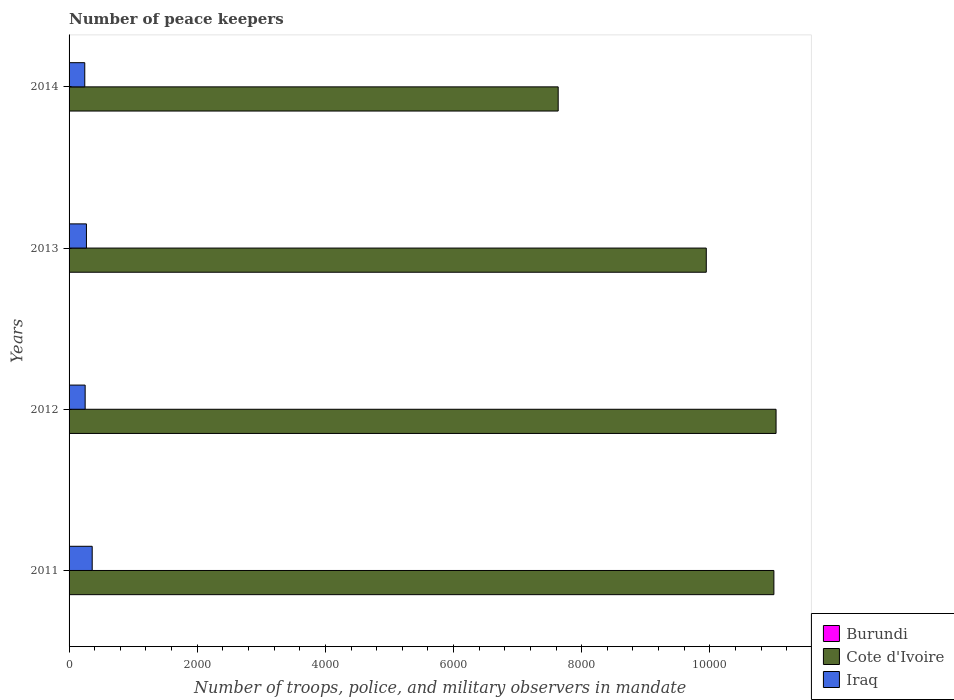How many groups of bars are there?
Ensure brevity in your answer.  4. Are the number of bars per tick equal to the number of legend labels?
Ensure brevity in your answer.  Yes. What is the label of the 3rd group of bars from the top?
Offer a terse response. 2012. What is the number of peace keepers in in Cote d'Ivoire in 2013?
Provide a succinct answer. 9944. Across all years, what is the maximum number of peace keepers in in Cote d'Ivoire?
Provide a succinct answer. 1.10e+04. Across all years, what is the minimum number of peace keepers in in Cote d'Ivoire?
Provide a succinct answer. 7633. In which year was the number of peace keepers in in Cote d'Ivoire maximum?
Provide a succinct answer. 2012. What is the total number of peace keepers in in Iraq in the graph?
Provide a succinct answer. 1128. What is the difference between the number of peace keepers in in Burundi in 2012 and that in 2014?
Provide a short and direct response. 0. What is the difference between the number of peace keepers in in Cote d'Ivoire in 2014 and the number of peace keepers in in Burundi in 2012?
Your answer should be compact. 7631. What is the average number of peace keepers in in Cote d'Ivoire per year?
Offer a terse response. 9902.25. In the year 2013, what is the difference between the number of peace keepers in in Burundi and number of peace keepers in in Cote d'Ivoire?
Make the answer very short. -9942. What is the ratio of the number of peace keepers in in Cote d'Ivoire in 2011 to that in 2012?
Provide a succinct answer. 1. Is the number of peace keepers in in Burundi in 2013 less than that in 2014?
Provide a short and direct response. No. What is the difference between the highest and the second highest number of peace keepers in in Cote d'Ivoire?
Offer a terse response. 34. What is the difference between the highest and the lowest number of peace keepers in in Burundi?
Provide a short and direct response. 1. Is the sum of the number of peace keepers in in Cote d'Ivoire in 2011 and 2012 greater than the maximum number of peace keepers in in Iraq across all years?
Provide a succinct answer. Yes. What does the 2nd bar from the top in 2013 represents?
Give a very brief answer. Cote d'Ivoire. What does the 3rd bar from the bottom in 2011 represents?
Keep it short and to the point. Iraq. Is it the case that in every year, the sum of the number of peace keepers in in Cote d'Ivoire and number of peace keepers in in Burundi is greater than the number of peace keepers in in Iraq?
Ensure brevity in your answer.  Yes. How many bars are there?
Your response must be concise. 12. Are all the bars in the graph horizontal?
Your answer should be very brief. Yes. What is the difference between two consecutive major ticks on the X-axis?
Keep it short and to the point. 2000. Does the graph contain any zero values?
Your response must be concise. No. How many legend labels are there?
Keep it short and to the point. 3. What is the title of the graph?
Provide a short and direct response. Number of peace keepers. What is the label or title of the X-axis?
Give a very brief answer. Number of troops, police, and military observers in mandate. What is the label or title of the Y-axis?
Provide a succinct answer. Years. What is the Number of troops, police, and military observers in mandate in Burundi in 2011?
Offer a terse response. 1. What is the Number of troops, police, and military observers in mandate of Cote d'Ivoire in 2011?
Provide a succinct answer. 1.10e+04. What is the Number of troops, police, and military observers in mandate in Iraq in 2011?
Make the answer very short. 361. What is the Number of troops, police, and military observers in mandate in Burundi in 2012?
Provide a succinct answer. 2. What is the Number of troops, police, and military observers in mandate in Cote d'Ivoire in 2012?
Make the answer very short. 1.10e+04. What is the Number of troops, police, and military observers in mandate in Iraq in 2012?
Provide a succinct answer. 251. What is the Number of troops, police, and military observers in mandate of Cote d'Ivoire in 2013?
Offer a terse response. 9944. What is the Number of troops, police, and military observers in mandate in Iraq in 2013?
Provide a succinct answer. 271. What is the Number of troops, police, and military observers in mandate in Burundi in 2014?
Your answer should be very brief. 2. What is the Number of troops, police, and military observers in mandate in Cote d'Ivoire in 2014?
Provide a short and direct response. 7633. What is the Number of troops, police, and military observers in mandate in Iraq in 2014?
Offer a very short reply. 245. Across all years, what is the maximum Number of troops, police, and military observers in mandate of Cote d'Ivoire?
Ensure brevity in your answer.  1.10e+04. Across all years, what is the maximum Number of troops, police, and military observers in mandate of Iraq?
Provide a short and direct response. 361. Across all years, what is the minimum Number of troops, police, and military observers in mandate of Cote d'Ivoire?
Your answer should be compact. 7633. Across all years, what is the minimum Number of troops, police, and military observers in mandate of Iraq?
Provide a short and direct response. 245. What is the total Number of troops, police, and military observers in mandate of Burundi in the graph?
Your answer should be compact. 7. What is the total Number of troops, police, and military observers in mandate of Cote d'Ivoire in the graph?
Provide a short and direct response. 3.96e+04. What is the total Number of troops, police, and military observers in mandate in Iraq in the graph?
Your response must be concise. 1128. What is the difference between the Number of troops, police, and military observers in mandate in Cote d'Ivoire in 2011 and that in 2012?
Your answer should be very brief. -34. What is the difference between the Number of troops, police, and military observers in mandate of Iraq in 2011 and that in 2012?
Your answer should be very brief. 110. What is the difference between the Number of troops, police, and military observers in mandate in Burundi in 2011 and that in 2013?
Your response must be concise. -1. What is the difference between the Number of troops, police, and military observers in mandate in Cote d'Ivoire in 2011 and that in 2013?
Give a very brief answer. 1055. What is the difference between the Number of troops, police, and military observers in mandate in Burundi in 2011 and that in 2014?
Make the answer very short. -1. What is the difference between the Number of troops, police, and military observers in mandate of Cote d'Ivoire in 2011 and that in 2014?
Provide a short and direct response. 3366. What is the difference between the Number of troops, police, and military observers in mandate of Iraq in 2011 and that in 2014?
Provide a short and direct response. 116. What is the difference between the Number of troops, police, and military observers in mandate in Burundi in 2012 and that in 2013?
Give a very brief answer. 0. What is the difference between the Number of troops, police, and military observers in mandate of Cote d'Ivoire in 2012 and that in 2013?
Offer a very short reply. 1089. What is the difference between the Number of troops, police, and military observers in mandate in Iraq in 2012 and that in 2013?
Give a very brief answer. -20. What is the difference between the Number of troops, police, and military observers in mandate in Cote d'Ivoire in 2012 and that in 2014?
Your response must be concise. 3400. What is the difference between the Number of troops, police, and military observers in mandate in Iraq in 2012 and that in 2014?
Provide a succinct answer. 6. What is the difference between the Number of troops, police, and military observers in mandate of Cote d'Ivoire in 2013 and that in 2014?
Keep it short and to the point. 2311. What is the difference between the Number of troops, police, and military observers in mandate in Burundi in 2011 and the Number of troops, police, and military observers in mandate in Cote d'Ivoire in 2012?
Make the answer very short. -1.10e+04. What is the difference between the Number of troops, police, and military observers in mandate of Burundi in 2011 and the Number of troops, police, and military observers in mandate of Iraq in 2012?
Make the answer very short. -250. What is the difference between the Number of troops, police, and military observers in mandate of Cote d'Ivoire in 2011 and the Number of troops, police, and military observers in mandate of Iraq in 2012?
Your response must be concise. 1.07e+04. What is the difference between the Number of troops, police, and military observers in mandate in Burundi in 2011 and the Number of troops, police, and military observers in mandate in Cote d'Ivoire in 2013?
Your answer should be compact. -9943. What is the difference between the Number of troops, police, and military observers in mandate of Burundi in 2011 and the Number of troops, police, and military observers in mandate of Iraq in 2013?
Provide a short and direct response. -270. What is the difference between the Number of troops, police, and military observers in mandate in Cote d'Ivoire in 2011 and the Number of troops, police, and military observers in mandate in Iraq in 2013?
Provide a short and direct response. 1.07e+04. What is the difference between the Number of troops, police, and military observers in mandate in Burundi in 2011 and the Number of troops, police, and military observers in mandate in Cote d'Ivoire in 2014?
Make the answer very short. -7632. What is the difference between the Number of troops, police, and military observers in mandate in Burundi in 2011 and the Number of troops, police, and military observers in mandate in Iraq in 2014?
Offer a terse response. -244. What is the difference between the Number of troops, police, and military observers in mandate in Cote d'Ivoire in 2011 and the Number of troops, police, and military observers in mandate in Iraq in 2014?
Ensure brevity in your answer.  1.08e+04. What is the difference between the Number of troops, police, and military observers in mandate in Burundi in 2012 and the Number of troops, police, and military observers in mandate in Cote d'Ivoire in 2013?
Your response must be concise. -9942. What is the difference between the Number of troops, police, and military observers in mandate in Burundi in 2012 and the Number of troops, police, and military observers in mandate in Iraq in 2013?
Your response must be concise. -269. What is the difference between the Number of troops, police, and military observers in mandate in Cote d'Ivoire in 2012 and the Number of troops, police, and military observers in mandate in Iraq in 2013?
Offer a terse response. 1.08e+04. What is the difference between the Number of troops, police, and military observers in mandate of Burundi in 2012 and the Number of troops, police, and military observers in mandate of Cote d'Ivoire in 2014?
Your answer should be very brief. -7631. What is the difference between the Number of troops, police, and military observers in mandate in Burundi in 2012 and the Number of troops, police, and military observers in mandate in Iraq in 2014?
Provide a succinct answer. -243. What is the difference between the Number of troops, police, and military observers in mandate in Cote d'Ivoire in 2012 and the Number of troops, police, and military observers in mandate in Iraq in 2014?
Your answer should be very brief. 1.08e+04. What is the difference between the Number of troops, police, and military observers in mandate in Burundi in 2013 and the Number of troops, police, and military observers in mandate in Cote d'Ivoire in 2014?
Give a very brief answer. -7631. What is the difference between the Number of troops, police, and military observers in mandate of Burundi in 2013 and the Number of troops, police, and military observers in mandate of Iraq in 2014?
Your answer should be very brief. -243. What is the difference between the Number of troops, police, and military observers in mandate of Cote d'Ivoire in 2013 and the Number of troops, police, and military observers in mandate of Iraq in 2014?
Provide a succinct answer. 9699. What is the average Number of troops, police, and military observers in mandate in Burundi per year?
Provide a short and direct response. 1.75. What is the average Number of troops, police, and military observers in mandate of Cote d'Ivoire per year?
Your answer should be compact. 9902.25. What is the average Number of troops, police, and military observers in mandate in Iraq per year?
Your answer should be compact. 282. In the year 2011, what is the difference between the Number of troops, police, and military observers in mandate in Burundi and Number of troops, police, and military observers in mandate in Cote d'Ivoire?
Keep it short and to the point. -1.10e+04. In the year 2011, what is the difference between the Number of troops, police, and military observers in mandate of Burundi and Number of troops, police, and military observers in mandate of Iraq?
Your answer should be very brief. -360. In the year 2011, what is the difference between the Number of troops, police, and military observers in mandate in Cote d'Ivoire and Number of troops, police, and military observers in mandate in Iraq?
Provide a succinct answer. 1.06e+04. In the year 2012, what is the difference between the Number of troops, police, and military observers in mandate in Burundi and Number of troops, police, and military observers in mandate in Cote d'Ivoire?
Make the answer very short. -1.10e+04. In the year 2012, what is the difference between the Number of troops, police, and military observers in mandate in Burundi and Number of troops, police, and military observers in mandate in Iraq?
Keep it short and to the point. -249. In the year 2012, what is the difference between the Number of troops, police, and military observers in mandate in Cote d'Ivoire and Number of troops, police, and military observers in mandate in Iraq?
Your answer should be very brief. 1.08e+04. In the year 2013, what is the difference between the Number of troops, police, and military observers in mandate in Burundi and Number of troops, police, and military observers in mandate in Cote d'Ivoire?
Keep it short and to the point. -9942. In the year 2013, what is the difference between the Number of troops, police, and military observers in mandate in Burundi and Number of troops, police, and military observers in mandate in Iraq?
Your response must be concise. -269. In the year 2013, what is the difference between the Number of troops, police, and military observers in mandate in Cote d'Ivoire and Number of troops, police, and military observers in mandate in Iraq?
Your answer should be very brief. 9673. In the year 2014, what is the difference between the Number of troops, police, and military observers in mandate in Burundi and Number of troops, police, and military observers in mandate in Cote d'Ivoire?
Offer a very short reply. -7631. In the year 2014, what is the difference between the Number of troops, police, and military observers in mandate of Burundi and Number of troops, police, and military observers in mandate of Iraq?
Provide a short and direct response. -243. In the year 2014, what is the difference between the Number of troops, police, and military observers in mandate in Cote d'Ivoire and Number of troops, police, and military observers in mandate in Iraq?
Provide a succinct answer. 7388. What is the ratio of the Number of troops, police, and military observers in mandate in Burundi in 2011 to that in 2012?
Keep it short and to the point. 0.5. What is the ratio of the Number of troops, police, and military observers in mandate in Cote d'Ivoire in 2011 to that in 2012?
Your answer should be very brief. 1. What is the ratio of the Number of troops, police, and military observers in mandate of Iraq in 2011 to that in 2012?
Offer a very short reply. 1.44. What is the ratio of the Number of troops, police, and military observers in mandate in Burundi in 2011 to that in 2013?
Provide a short and direct response. 0.5. What is the ratio of the Number of troops, police, and military observers in mandate in Cote d'Ivoire in 2011 to that in 2013?
Offer a very short reply. 1.11. What is the ratio of the Number of troops, police, and military observers in mandate of Iraq in 2011 to that in 2013?
Provide a succinct answer. 1.33. What is the ratio of the Number of troops, police, and military observers in mandate of Burundi in 2011 to that in 2014?
Keep it short and to the point. 0.5. What is the ratio of the Number of troops, police, and military observers in mandate in Cote d'Ivoire in 2011 to that in 2014?
Your response must be concise. 1.44. What is the ratio of the Number of troops, police, and military observers in mandate of Iraq in 2011 to that in 2014?
Give a very brief answer. 1.47. What is the ratio of the Number of troops, police, and military observers in mandate in Cote d'Ivoire in 2012 to that in 2013?
Provide a succinct answer. 1.11. What is the ratio of the Number of troops, police, and military observers in mandate of Iraq in 2012 to that in 2013?
Ensure brevity in your answer.  0.93. What is the ratio of the Number of troops, police, and military observers in mandate of Burundi in 2012 to that in 2014?
Provide a succinct answer. 1. What is the ratio of the Number of troops, police, and military observers in mandate in Cote d'Ivoire in 2012 to that in 2014?
Provide a short and direct response. 1.45. What is the ratio of the Number of troops, police, and military observers in mandate of Iraq in 2012 to that in 2014?
Make the answer very short. 1.02. What is the ratio of the Number of troops, police, and military observers in mandate of Burundi in 2013 to that in 2014?
Ensure brevity in your answer.  1. What is the ratio of the Number of troops, police, and military observers in mandate of Cote d'Ivoire in 2013 to that in 2014?
Provide a short and direct response. 1.3. What is the ratio of the Number of troops, police, and military observers in mandate in Iraq in 2013 to that in 2014?
Keep it short and to the point. 1.11. What is the difference between the highest and the second highest Number of troops, police, and military observers in mandate in Cote d'Ivoire?
Provide a short and direct response. 34. What is the difference between the highest and the second highest Number of troops, police, and military observers in mandate in Iraq?
Your answer should be very brief. 90. What is the difference between the highest and the lowest Number of troops, police, and military observers in mandate of Cote d'Ivoire?
Make the answer very short. 3400. What is the difference between the highest and the lowest Number of troops, police, and military observers in mandate in Iraq?
Provide a short and direct response. 116. 